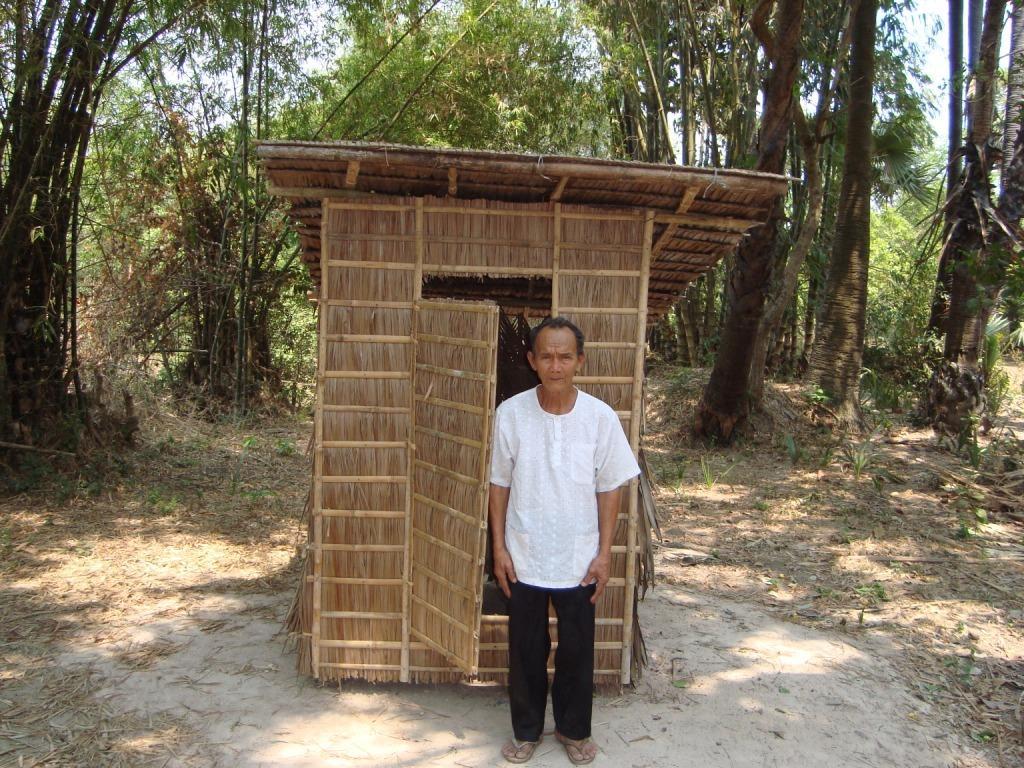Please provide a concise description of this image. In this image we can see a person wearing white color shirt, black color pant standing near the wooden hurt and at the background of the image there are some trees and clear sky. 